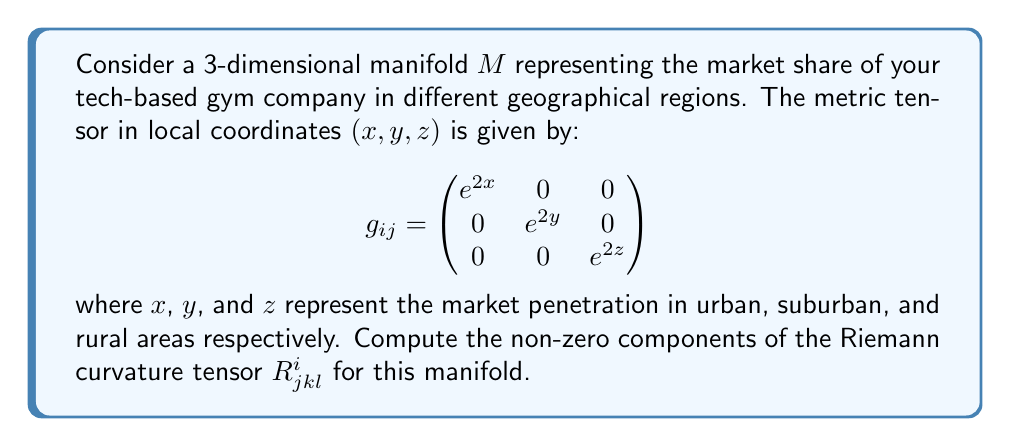Provide a solution to this math problem. To compute the Riemann curvature tensor, we'll follow these steps:

1) First, we need to calculate the Christoffel symbols $\Gamma^i_{jk}$ using the formula:

   $$\Gamma^i_{jk} = \frac{1}{2}g^{im}(\partial_j g_{km} + \partial_k g_{jm} - \partial_m g_{jk})$$

2) The inverse metric tensor $g^{ij}$ is:

   $$g^{ij} = \begin{pmatrix}
   e^{-2x} & 0 & 0 \\
   0 & e^{-2y} & 0 \\
   0 & 0 & e^{-2z}
   \end{pmatrix}$$

3) Calculating the non-zero Christoffel symbols:

   $\Gamma^1_{11} = 1$, $\Gamma^2_{22} = 1$, $\Gamma^3_{33} = 1$

4) Now, we can compute the Riemann curvature tensor using the formula:

   $$R^i_{jkl} = \partial_k \Gamma^i_{jl} - \partial_l \Gamma^i_{jk} + \Gamma^i_{km}\Gamma^m_{jl} - \Gamma^i_{lm}\Gamma^m_{jk}$$

5) The non-zero components are:

   $R^1_{212} = R^1_{221} = -e^{2(x-y)}$
   $R^1_{313} = R^1_{331} = -e^{2(x-z)}$
   $R^2_{121} = R^2_{112} = -e^{2(y-x)}$
   $R^2_{323} = R^2_{332} = -e^{2(y-z)}$
   $R^3_{131} = R^3_{113} = -e^{2(z-x)}$
   $R^3_{232} = R^3_{223} = -e^{2(z-y)}$

These components represent the curvature of the market share manifold in different directions, indicating how the market share changes across different geographical regions.
Answer: The non-zero components of the Riemann curvature tensor are:

$$\begin{aligned}
R^1_{212} &= R^1_{221} = -e^{2(x-y)} \\
R^1_{313} &= R^1_{331} = -e^{2(x-z)} \\
R^2_{121} &= R^2_{112} = -e^{2(y-x)} \\
R^2_{323} &= R^2_{332} = -e^{2(y-z)} \\
R^3_{131} &= R^3_{113} = -e^{2(z-x)} \\
R^3_{232} &= R^3_{223} = -e^{2(z-y)}
\end{aligned}$$ 